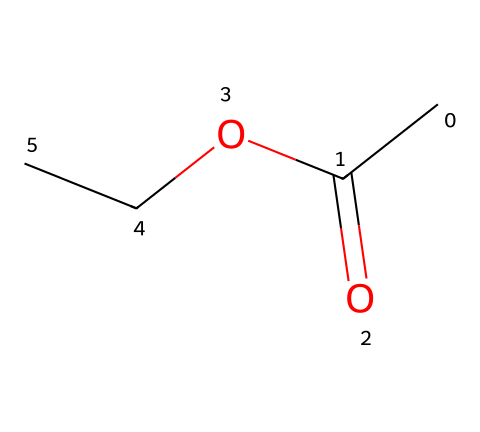What is the molecular formula of ethyl acetate? By analyzing the chemical structure represented by the SMILES notation, we identify the presence of two carbon atoms (C), four hydrogen atoms (H), and two oxygen atoms (O). Thus, the molecular formula can be constructed as C4H8O2.
Answer: C4H8O2 How many carbon atoms are in ethyl acetate? The chemical structure indicated by the SMILES shows that there are two pairs of carbon atoms, one from the acetate part (CH3COO) and another from the ethyl group (C2H5), totaling two carbon atoms.
Answer: 4 What functional group is present in ethyl acetate? The SMILES expression reveals an ester functional group, characterized by a carbonyl (C=O) connected to an alkoxy group (O-R). This is confirmed by observing the presence of the -COO- segment in the structure.
Answer: ester Is ethyl acetate polar or nonpolar? Analyzing the chemical structure reveals that ethyl acetate contains polar bonds due to the electronegativity difference between carbon, oxygen, and hydrogen. However, its overall structure leads to a net dipole moment, making it a polar molecule.
Answer: polar What type of reaction can ethyl acetate undergo? Ethyl acetate can undergo hydrolysis, where it reacts with water to form ethanol and acetic acid. This is due to the reactivity of the ester functional group when in contact with water, making it susceptible to nucleophilic attack.
Answer: hydrolysis How many hydrogen atoms are in ethyl acetate? From the chemical structure derived from the SMILES, the ethyl group contributes 5 hydrogen atoms and the acetate group contributes 3 hydrogen atoms, resulting in a total of 8 hydrogen atoms in ethyl acetate.
Answer: 8 